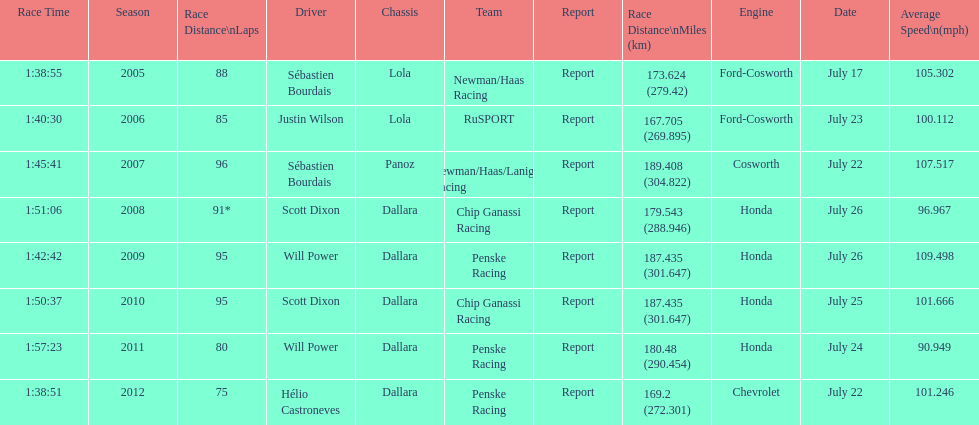How many flags other than france (the first flag) are represented? 3. 